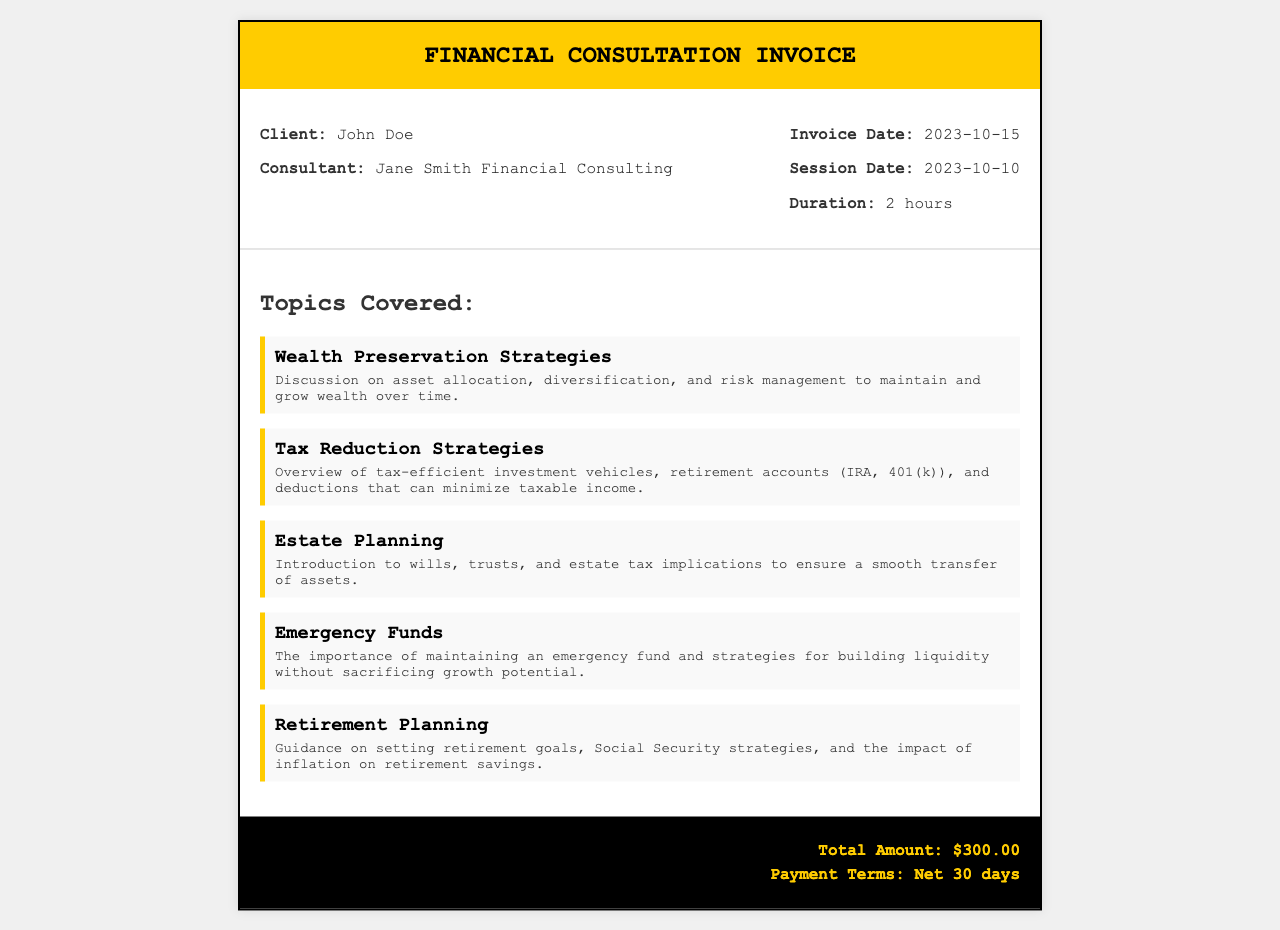What is the client's name? The client's name is specified in the document, indicating who received the service.
Answer: John Doe What is the consultant's name? The document lists the name of the consulting firm or individual who provided the service.
Answer: Jane Smith Financial Consulting What was the session date? This refers to the date when the consulting session took place, which is recorded in the invoice.
Answer: 2023-10-10 How long did the consultation last? The duration of the session is explicitly mentioned in the document, showing how long the service was provided.
Answer: 2 hours What is the total amount due? The total amount due is clearly stated at the bottom of the invoice for transparency regarding payment.
Answer: $300.00 What type of strategies were discussed regarding wealth? The section heading indicates the nature of financial strategies covered in the consultation.
Answer: Wealth Preservation Strategies Which tax-efficient accounts were mentioned? The document specifies certain accounts that are included in tax reduction discussions, highlighting financial planning options.
Answer: IRA, 401(k) What is the payment terms for the invoice? The payment terms provide information on when payment is expected, essential for financial agreements.
Answer: Net 30 days How many topics were covered in the consultation? This refers to the total number of distinct subjects addressed during the consulting session.
Answer: Five 